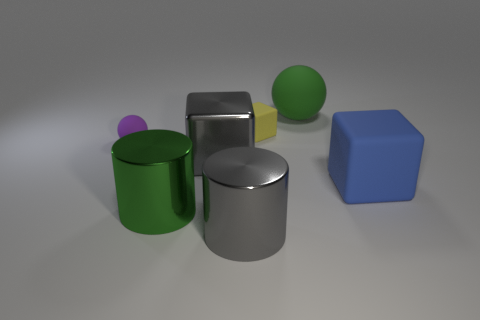Subtract all large metallic blocks. How many blocks are left? 2 Subtract all cubes. How many objects are left? 4 Subtract all blue blocks. How many blocks are left? 2 Subtract all brown spheres. How many gray cylinders are left? 1 Subtract 2 blocks. How many blocks are left? 1 Subtract all purple cubes. Subtract all red balls. How many cubes are left? 3 Subtract all small purple things. Subtract all large blue rubber objects. How many objects are left? 5 Add 7 blue rubber cubes. How many blue rubber cubes are left? 8 Add 1 big blue blocks. How many big blue blocks exist? 2 Add 3 big yellow metal things. How many objects exist? 10 